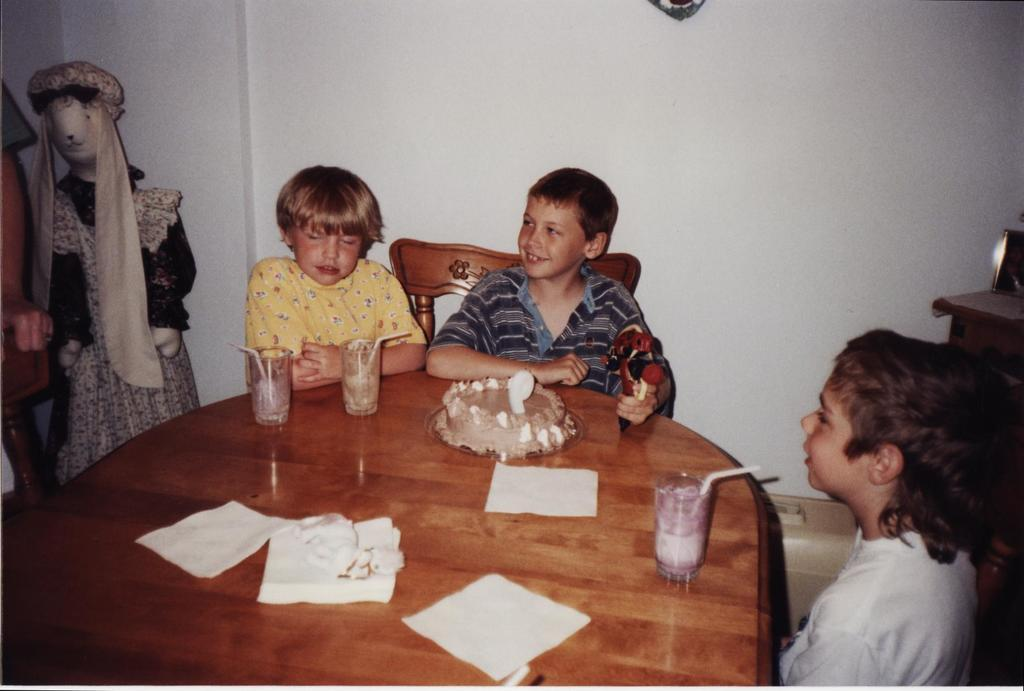How many people are in the image? There are three persons in the image. What is present on the table in the image? There are glasses, a cake, and papers on the table. Is there any seating visible in the image? Yes, there is a chair in the image. What else can be seen in the image besides the people and table? There is a toy and a wall in the background of the image. What type of bushes can be seen growing near the wall in the image? There are no bushes present in the image; only a wall is visible in the background. What type of pan is being used to cook the cake in the image? There is no pan visible in the image, as the cake is already on the table. 